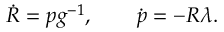<formula> <loc_0><loc_0><loc_500><loc_500>\begin{array} { r } { \dot { R } = p g ^ { - 1 } , \quad \dot { p } = - R \lambda . } \end{array}</formula> 